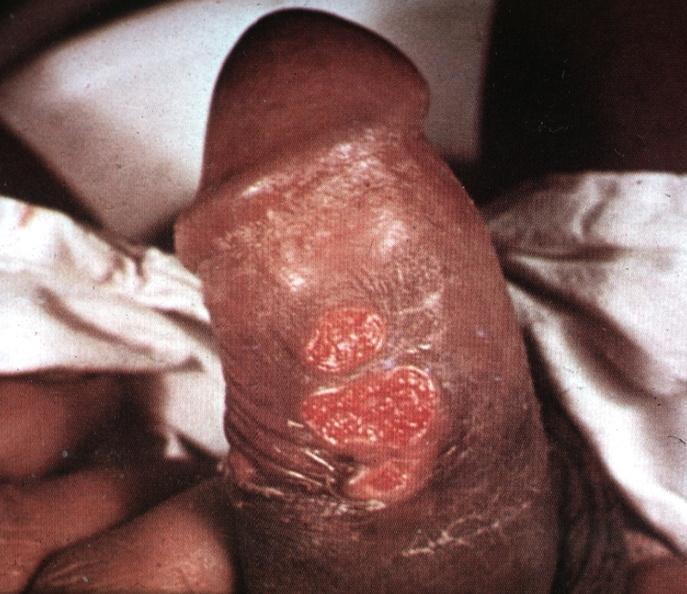does postoperative cardiac surgery show that ulcerative lesions slide is labeled chancroid?
Answer the question using a single word or phrase. No 